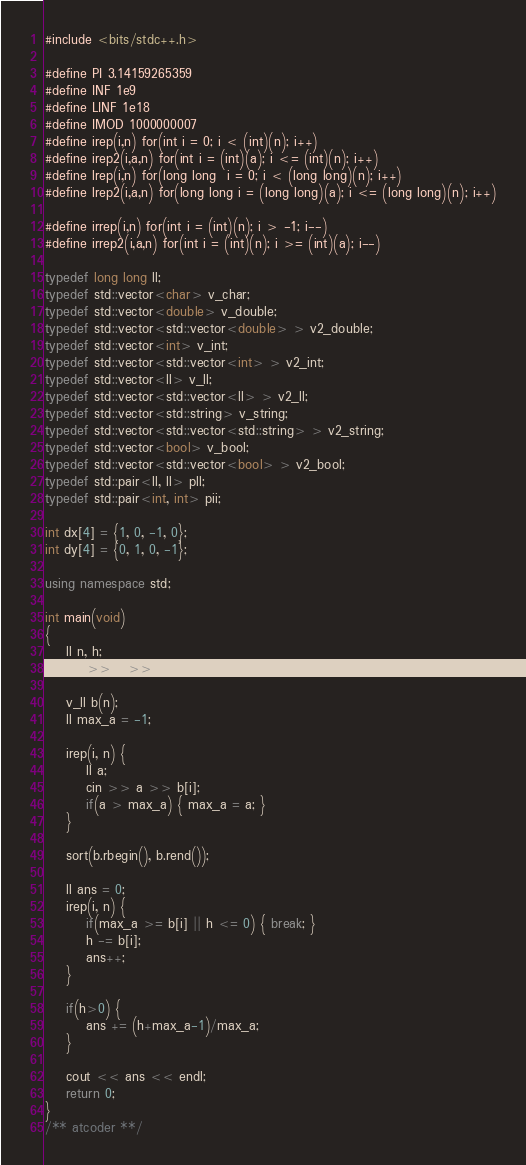Convert code to text. <code><loc_0><loc_0><loc_500><loc_500><_C++_>#include <bits/stdc++.h>

#define PI 3.14159265359
#define INF 1e9
#define LINF 1e18
#define IMOD 1000000007 
#define irep(i,n) for(int i = 0; i < (int)(n); i++)
#define irep2(i,a,n) for(int i = (int)(a); i <= (int)(n); i++)
#define lrep(i,n) for(long long  i = 0; i < (long long)(n); i++)
#define lrep2(i,a,n) for(long long i = (long long)(a); i <= (long long)(n); i++)

#define irrep(i,n) for(int i = (int)(n); i > -1; i--)
#define irrep2(i,a,n) for(int i = (int)(n); i >= (int)(a); i--)

typedef long long ll;
typedef std::vector<char> v_char;
typedef std::vector<double> v_double;
typedef std::vector<std::vector<double> > v2_double;
typedef std::vector<int> v_int;
typedef std::vector<std::vector<int> > v2_int;
typedef std::vector<ll> v_ll;
typedef std::vector<std::vector<ll> > v2_ll;
typedef std::vector<std::string> v_string;
typedef std::vector<std::vector<std::string> > v2_string;
typedef std::vector<bool> v_bool;
typedef std::vector<std::vector<bool> > v2_bool;
typedef std::pair<ll, ll> pll;
typedef std::pair<int, int> pii;

int dx[4] = {1, 0, -1, 0};
int dy[4] = {0, 1, 0, -1};

using namespace std; 

int main(void)
{
    ll n, h;
    cin >> n >> h;
    
    v_ll b(n);
    ll max_a = -1;

    irep(i, n) {
        ll a; 
        cin >> a >> b[i];
        if(a > max_a) { max_a = a; }
    }

    sort(b.rbegin(), b.rend());

    ll ans = 0;
    irep(i, n) {
        if(max_a >= b[i] || h <= 0) { break; }
        h -= b[i];
        ans++;
    }

    if(h>0) {
        ans += (h+max_a-1)/max_a;
    }

    cout << ans << endl;
    return 0;
}
/** atcoder **/
</code> 